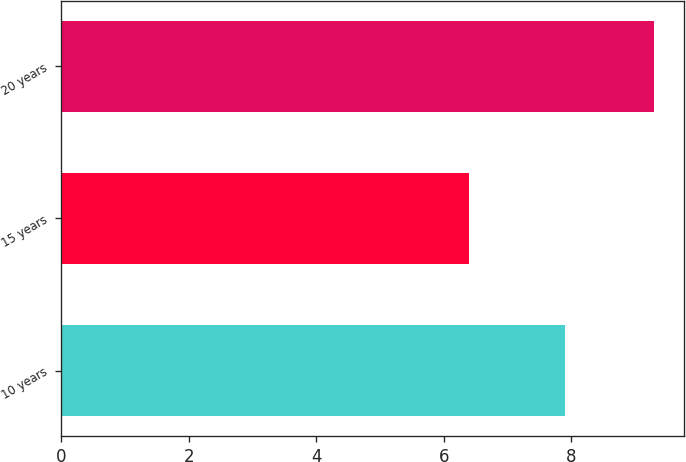Convert chart. <chart><loc_0><loc_0><loc_500><loc_500><bar_chart><fcel>10 years<fcel>15 years<fcel>20 years<nl><fcel>7.9<fcel>6.4<fcel>9.3<nl></chart> 